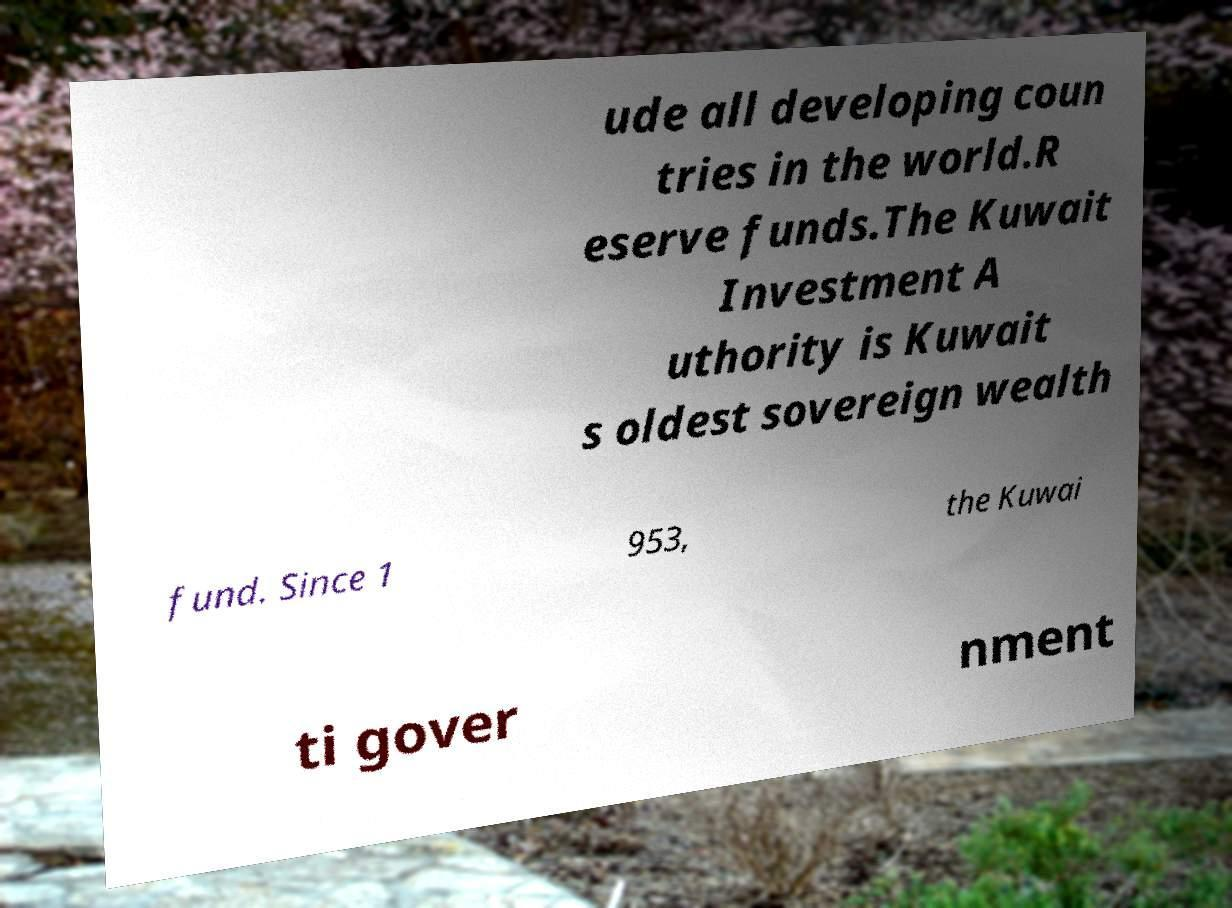Could you assist in decoding the text presented in this image and type it out clearly? ude all developing coun tries in the world.R eserve funds.The Kuwait Investment A uthority is Kuwait s oldest sovereign wealth fund. Since 1 953, the Kuwai ti gover nment 